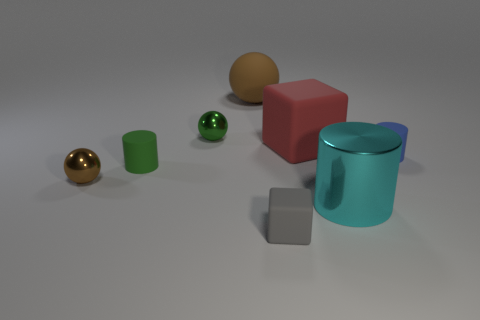There is another tiny object that is the same shape as the small brown metal thing; what is its color?
Your answer should be very brief. Green. Are there more matte cylinders that are on the left side of the tiny gray object than metal balls?
Provide a short and direct response. No. The small matte cylinder right of the green rubber thing is what color?
Ensure brevity in your answer.  Blue. Do the green matte object and the cyan cylinder have the same size?
Provide a succinct answer. No. The green rubber cylinder has what size?
Ensure brevity in your answer.  Small. Are there more large cyan objects than red metal objects?
Offer a very short reply. Yes. What color is the tiny sphere in front of the red rubber object that is behind the brown ball that is in front of the small green metal object?
Offer a terse response. Brown. Is the shape of the metallic thing that is on the right side of the red thing the same as  the large red object?
Give a very brief answer. No. The ball that is the same size as the cyan metal thing is what color?
Your answer should be very brief. Brown. How many tiny blue spheres are there?
Offer a very short reply. 0. 